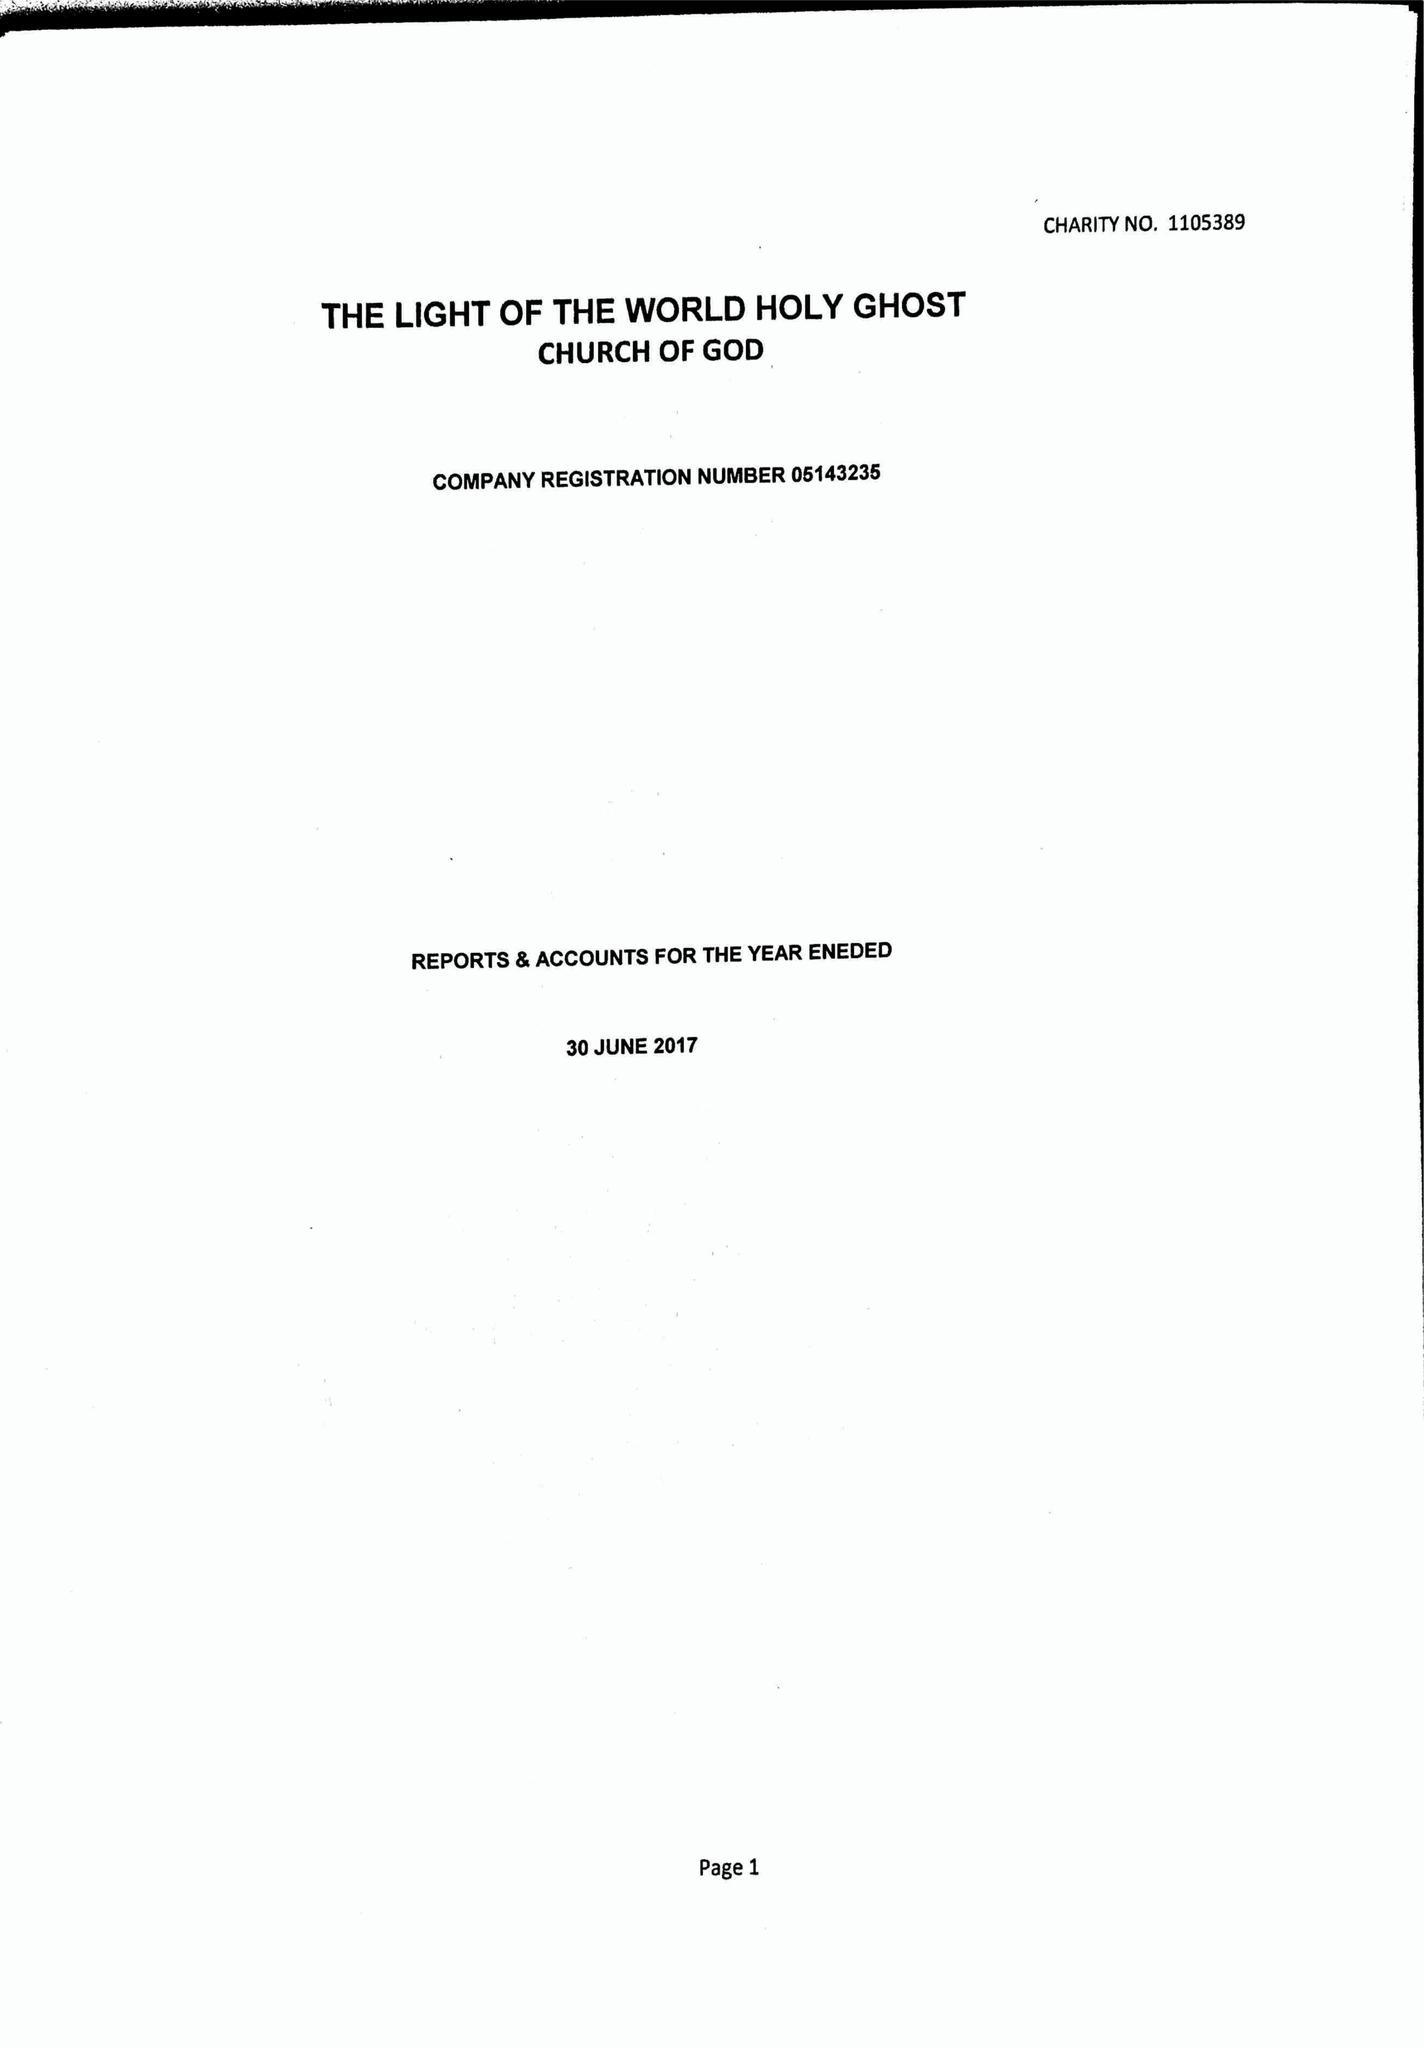What is the value for the report_date?
Answer the question using a single word or phrase. 2017-06-30 